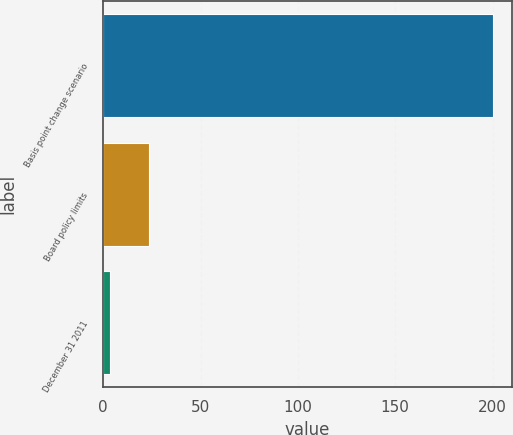Convert chart to OTSL. <chart><loc_0><loc_0><loc_500><loc_500><bar_chart><fcel>Basis point change scenario<fcel>Board policy limits<fcel>December 31 2011<nl><fcel>200<fcel>23.24<fcel>3.6<nl></chart> 